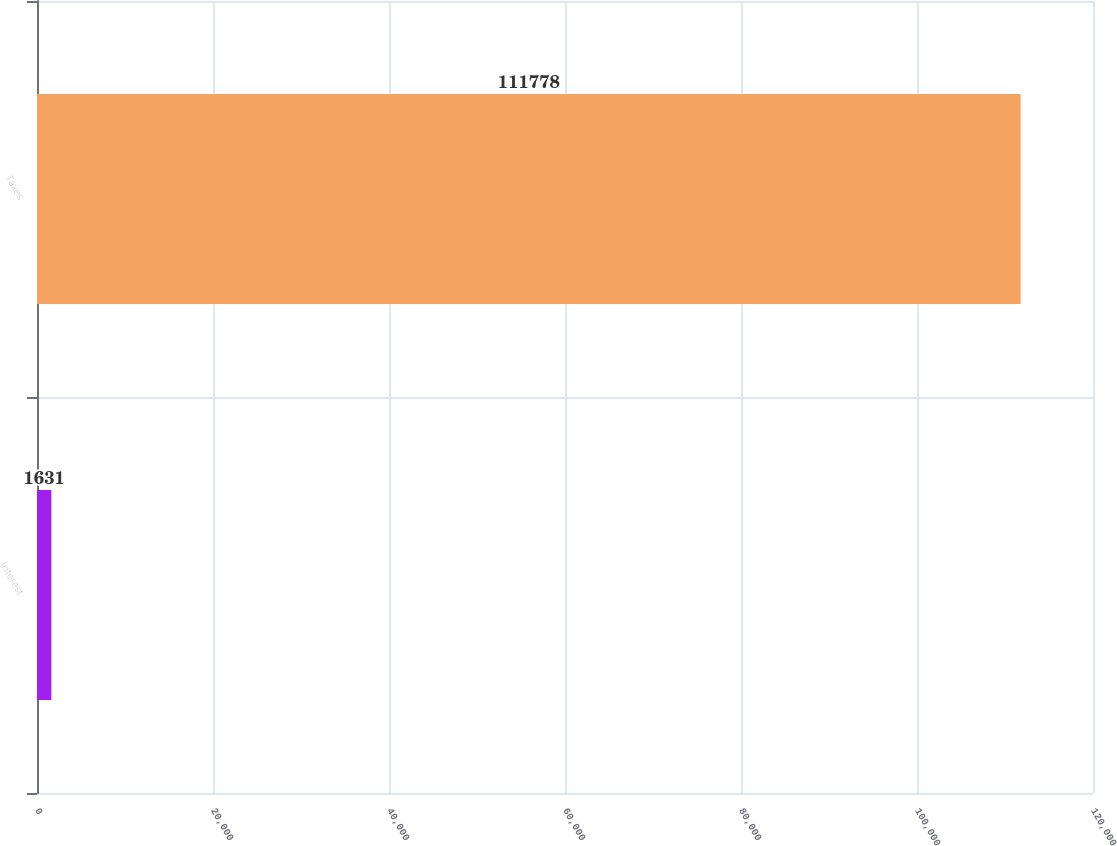Convert chart. <chart><loc_0><loc_0><loc_500><loc_500><bar_chart><fcel>Interest<fcel>Taxes<nl><fcel>1631<fcel>111778<nl></chart> 